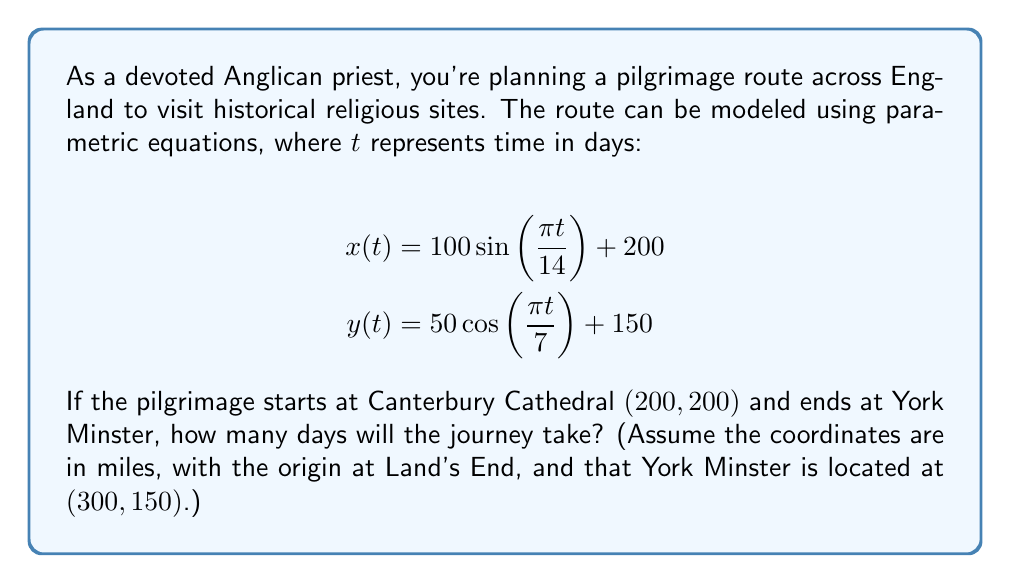What is the answer to this math problem? To solve this problem, we need to determine when the parametric equations yield the coordinates of York Minster. We'll follow these steps:

1) The pilgrimage starts at Canterbury Cathedral $(200, 200)$. Let's verify this is true when $t=0$:

   $x(0) = 100 \sin(0) + 200 = 200$
   $y(0) = 50 \cos(0) + 150 = 200$

2) Now, we need to find when $x(t) = 300$ and $y(t) = 150$ simultaneously. This will be the end of the journey at York Minster.

3) For $y(t)$:
   $150 = 50 \cos(\frac{\pi t}{7}) + 150$
   $0 = \cos(\frac{\pi t}{7})$
   $\frac{\pi t}{7} = \frac{\pi}{2}$ (since cosine is 0 at $\frac{\pi}{2}$)
   $t = 7$ days

4) Let's verify this also works for $x(t)$:
   $x(7) = 100 \sin(\frac{\pi \cdot 7}{14}) + 200$
   $= 100 \sin(\frac{\pi}{2}) + 200$
   $= 100 + 200 = 300$

5) Therefore, the journey takes 7 days to reach York Minster.

This pilgrimage route, modeled by these equations, beautifully represents the spiritual journey from Canterbury to York, two of the most significant sites in Anglican history. The sinusoidal nature of the path could be seen as symbolic of the ups and downs of spiritual growth during the pilgrimage.
Answer: The pilgrimage journey from Canterbury Cathedral to York Minster will take 7 days. 